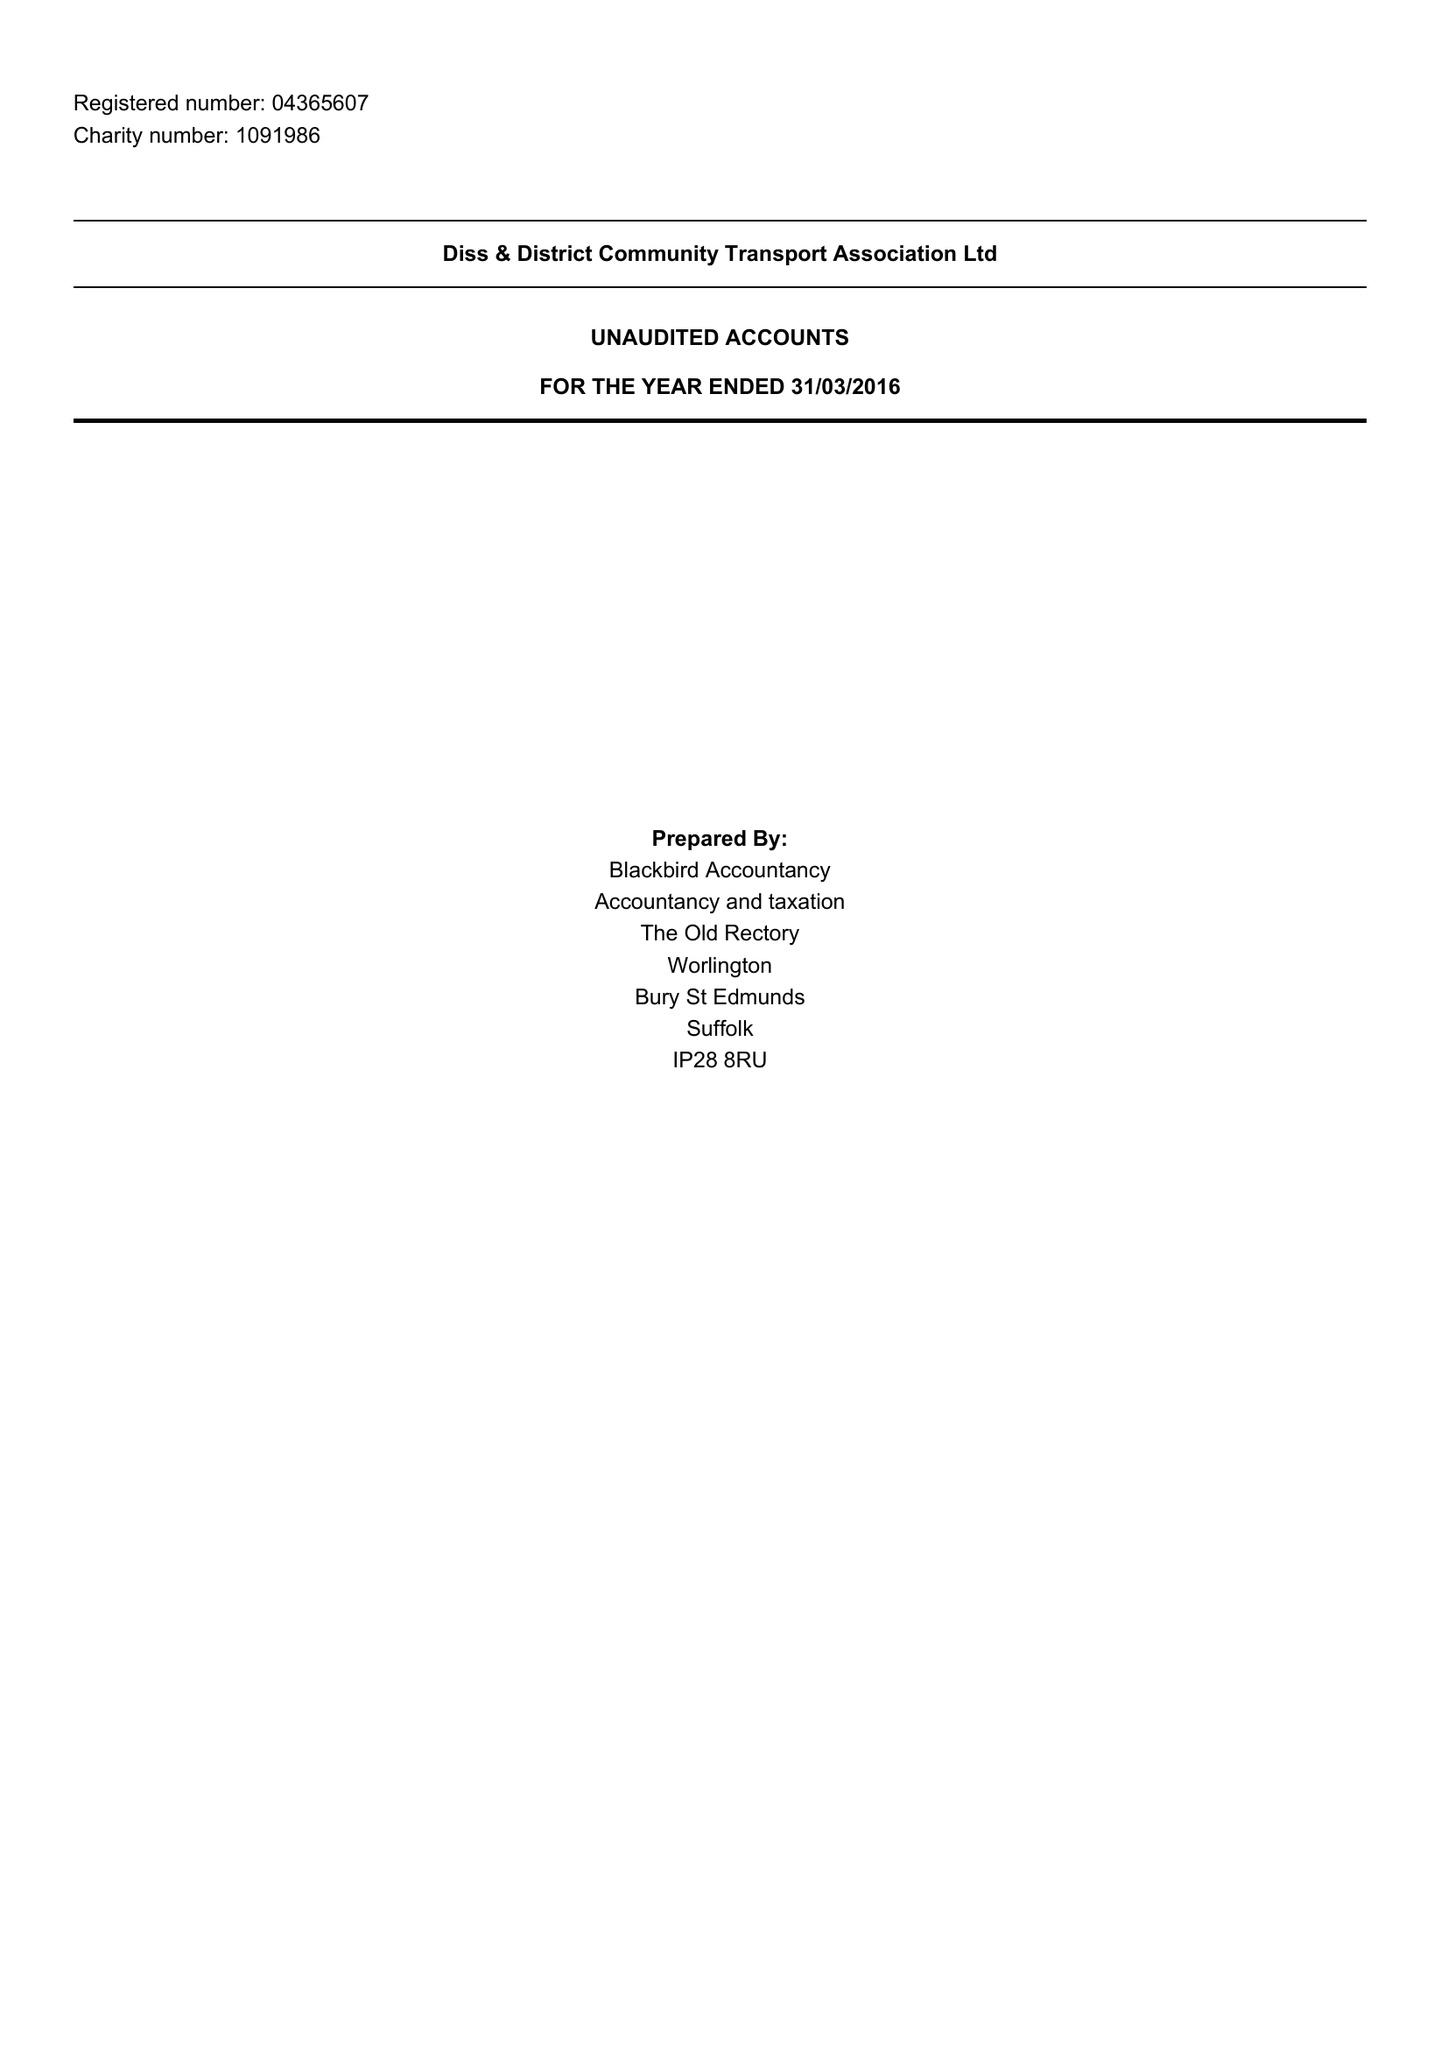What is the value for the address__post_town?
Answer the question using a single word or phrase. EYE 